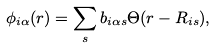<formula> <loc_0><loc_0><loc_500><loc_500>\phi _ { i \alpha } ( { r } ) = \sum _ { s } b _ { i \alpha s } \Theta ( { r } - { R } _ { i s } ) ,</formula> 